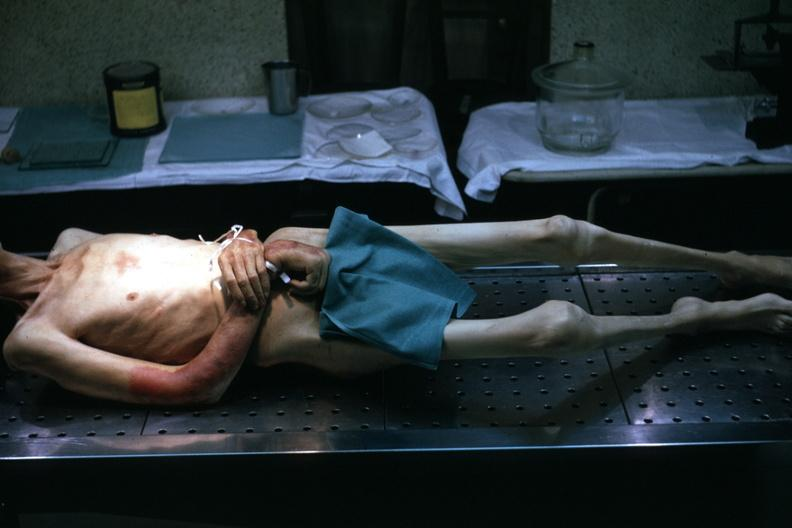what covered muscle atrophy is striking?
Answer the question using a single word or phrase. Good example tastefully shown with face out of picture and genitalia 